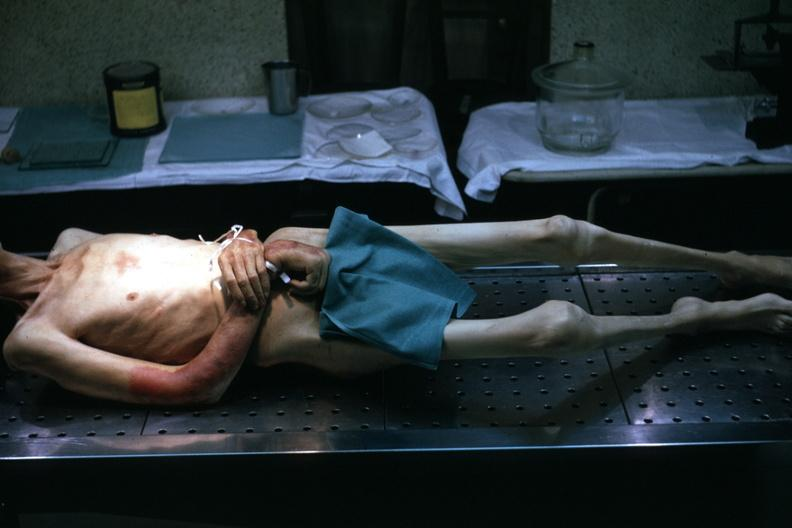what covered muscle atrophy is striking?
Answer the question using a single word or phrase. Good example tastefully shown with face out of picture and genitalia 